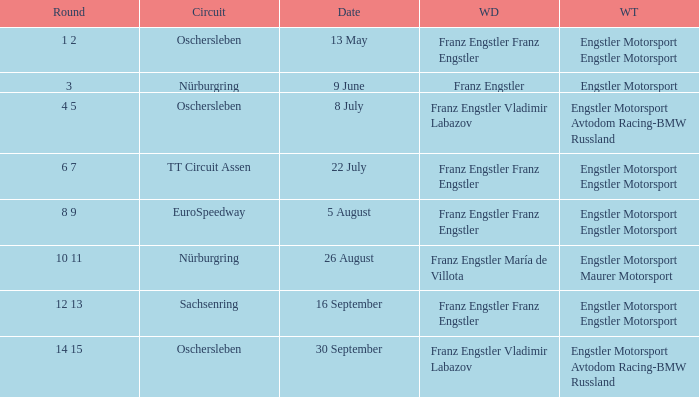What Round was the Winning Team Engstler Motorsport Maurer Motorsport? 10 11. 